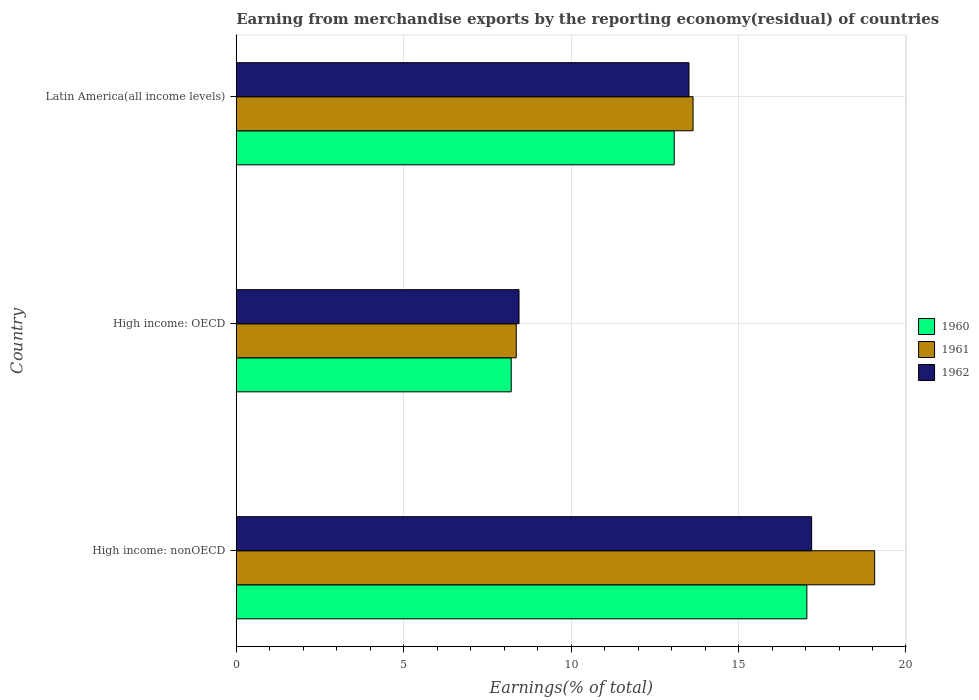How many different coloured bars are there?
Make the answer very short. 3. How many bars are there on the 2nd tick from the bottom?
Keep it short and to the point. 3. What is the label of the 1st group of bars from the top?
Give a very brief answer. Latin America(all income levels). What is the percentage of amount earned from merchandise exports in 1961 in Latin America(all income levels)?
Offer a very short reply. 13.64. Across all countries, what is the maximum percentage of amount earned from merchandise exports in 1960?
Give a very brief answer. 17.04. Across all countries, what is the minimum percentage of amount earned from merchandise exports in 1961?
Your answer should be very brief. 8.36. In which country was the percentage of amount earned from merchandise exports in 1961 maximum?
Offer a very short reply. High income: nonOECD. In which country was the percentage of amount earned from merchandise exports in 1960 minimum?
Make the answer very short. High income: OECD. What is the total percentage of amount earned from merchandise exports in 1961 in the graph?
Offer a terse response. 41.07. What is the difference between the percentage of amount earned from merchandise exports in 1960 in High income: OECD and that in High income: nonOECD?
Provide a succinct answer. -8.83. What is the difference between the percentage of amount earned from merchandise exports in 1961 in High income: OECD and the percentage of amount earned from merchandise exports in 1962 in High income: nonOECD?
Ensure brevity in your answer.  -8.82. What is the average percentage of amount earned from merchandise exports in 1962 per country?
Offer a terse response. 13.05. What is the difference between the percentage of amount earned from merchandise exports in 1960 and percentage of amount earned from merchandise exports in 1961 in High income: OECD?
Provide a short and direct response. -0.15. In how many countries, is the percentage of amount earned from merchandise exports in 1961 greater than 6 %?
Offer a very short reply. 3. What is the ratio of the percentage of amount earned from merchandise exports in 1960 in High income: OECD to that in Latin America(all income levels)?
Offer a terse response. 0.63. What is the difference between the highest and the second highest percentage of amount earned from merchandise exports in 1962?
Your answer should be compact. 3.66. What is the difference between the highest and the lowest percentage of amount earned from merchandise exports in 1960?
Your response must be concise. 8.83. In how many countries, is the percentage of amount earned from merchandise exports in 1961 greater than the average percentage of amount earned from merchandise exports in 1961 taken over all countries?
Keep it short and to the point. 1. What does the 3rd bar from the top in Latin America(all income levels) represents?
Ensure brevity in your answer.  1960. Are all the bars in the graph horizontal?
Your response must be concise. Yes. How many countries are there in the graph?
Offer a very short reply. 3. Are the values on the major ticks of X-axis written in scientific E-notation?
Your response must be concise. No. How many legend labels are there?
Offer a terse response. 3. How are the legend labels stacked?
Offer a very short reply. Vertical. What is the title of the graph?
Offer a terse response. Earning from merchandise exports by the reporting economy(residual) of countries. What is the label or title of the X-axis?
Provide a short and direct response. Earnings(% of total). What is the Earnings(% of total) of 1960 in High income: nonOECD?
Offer a terse response. 17.04. What is the Earnings(% of total) of 1961 in High income: nonOECD?
Provide a succinct answer. 19.06. What is the Earnings(% of total) of 1962 in High income: nonOECD?
Offer a terse response. 17.18. What is the Earnings(% of total) of 1960 in High income: OECD?
Offer a terse response. 8.21. What is the Earnings(% of total) of 1961 in High income: OECD?
Provide a succinct answer. 8.36. What is the Earnings(% of total) in 1962 in High income: OECD?
Ensure brevity in your answer.  8.44. What is the Earnings(% of total) in 1960 in Latin America(all income levels)?
Give a very brief answer. 13.08. What is the Earnings(% of total) of 1961 in Latin America(all income levels)?
Your answer should be very brief. 13.64. What is the Earnings(% of total) in 1962 in Latin America(all income levels)?
Provide a short and direct response. 13.52. Across all countries, what is the maximum Earnings(% of total) of 1960?
Offer a terse response. 17.04. Across all countries, what is the maximum Earnings(% of total) in 1961?
Your response must be concise. 19.06. Across all countries, what is the maximum Earnings(% of total) of 1962?
Your answer should be compact. 17.18. Across all countries, what is the minimum Earnings(% of total) of 1960?
Your response must be concise. 8.21. Across all countries, what is the minimum Earnings(% of total) of 1961?
Make the answer very short. 8.36. Across all countries, what is the minimum Earnings(% of total) of 1962?
Provide a short and direct response. 8.44. What is the total Earnings(% of total) in 1960 in the graph?
Ensure brevity in your answer.  38.33. What is the total Earnings(% of total) in 1961 in the graph?
Your answer should be very brief. 41.07. What is the total Earnings(% of total) in 1962 in the graph?
Offer a terse response. 39.15. What is the difference between the Earnings(% of total) in 1960 in High income: nonOECD and that in High income: OECD?
Provide a succinct answer. 8.83. What is the difference between the Earnings(% of total) of 1961 in High income: nonOECD and that in High income: OECD?
Offer a very short reply. 10.7. What is the difference between the Earnings(% of total) in 1962 in High income: nonOECD and that in High income: OECD?
Offer a very short reply. 8.74. What is the difference between the Earnings(% of total) in 1960 in High income: nonOECD and that in Latin America(all income levels)?
Your answer should be very brief. 3.96. What is the difference between the Earnings(% of total) in 1961 in High income: nonOECD and that in Latin America(all income levels)?
Keep it short and to the point. 5.42. What is the difference between the Earnings(% of total) of 1962 in High income: nonOECD and that in Latin America(all income levels)?
Your answer should be compact. 3.66. What is the difference between the Earnings(% of total) in 1960 in High income: OECD and that in Latin America(all income levels)?
Offer a terse response. -4.87. What is the difference between the Earnings(% of total) in 1961 in High income: OECD and that in Latin America(all income levels)?
Make the answer very short. -5.28. What is the difference between the Earnings(% of total) in 1962 in High income: OECD and that in Latin America(all income levels)?
Keep it short and to the point. -5.08. What is the difference between the Earnings(% of total) in 1960 in High income: nonOECD and the Earnings(% of total) in 1961 in High income: OECD?
Keep it short and to the point. 8.68. What is the difference between the Earnings(% of total) in 1960 in High income: nonOECD and the Earnings(% of total) in 1962 in High income: OECD?
Your response must be concise. 8.6. What is the difference between the Earnings(% of total) in 1961 in High income: nonOECD and the Earnings(% of total) in 1962 in High income: OECD?
Keep it short and to the point. 10.62. What is the difference between the Earnings(% of total) of 1960 in High income: nonOECD and the Earnings(% of total) of 1961 in Latin America(all income levels)?
Offer a terse response. 3.4. What is the difference between the Earnings(% of total) in 1960 in High income: nonOECD and the Earnings(% of total) in 1962 in Latin America(all income levels)?
Provide a short and direct response. 3.52. What is the difference between the Earnings(% of total) of 1961 in High income: nonOECD and the Earnings(% of total) of 1962 in Latin America(all income levels)?
Ensure brevity in your answer.  5.54. What is the difference between the Earnings(% of total) of 1960 in High income: OECD and the Earnings(% of total) of 1961 in Latin America(all income levels)?
Provide a short and direct response. -5.43. What is the difference between the Earnings(% of total) of 1960 in High income: OECD and the Earnings(% of total) of 1962 in Latin America(all income levels)?
Give a very brief answer. -5.31. What is the difference between the Earnings(% of total) of 1961 in High income: OECD and the Earnings(% of total) of 1962 in Latin America(all income levels)?
Give a very brief answer. -5.16. What is the average Earnings(% of total) in 1960 per country?
Offer a very short reply. 12.78. What is the average Earnings(% of total) in 1961 per country?
Give a very brief answer. 13.69. What is the average Earnings(% of total) of 1962 per country?
Make the answer very short. 13.05. What is the difference between the Earnings(% of total) of 1960 and Earnings(% of total) of 1961 in High income: nonOECD?
Your answer should be compact. -2.02. What is the difference between the Earnings(% of total) of 1960 and Earnings(% of total) of 1962 in High income: nonOECD?
Provide a succinct answer. -0.14. What is the difference between the Earnings(% of total) of 1961 and Earnings(% of total) of 1962 in High income: nonOECD?
Give a very brief answer. 1.88. What is the difference between the Earnings(% of total) of 1960 and Earnings(% of total) of 1961 in High income: OECD?
Provide a short and direct response. -0.15. What is the difference between the Earnings(% of total) in 1960 and Earnings(% of total) in 1962 in High income: OECD?
Your answer should be very brief. -0.23. What is the difference between the Earnings(% of total) in 1961 and Earnings(% of total) in 1962 in High income: OECD?
Ensure brevity in your answer.  -0.08. What is the difference between the Earnings(% of total) of 1960 and Earnings(% of total) of 1961 in Latin America(all income levels)?
Offer a very short reply. -0.56. What is the difference between the Earnings(% of total) in 1960 and Earnings(% of total) in 1962 in Latin America(all income levels)?
Keep it short and to the point. -0.44. What is the difference between the Earnings(% of total) of 1961 and Earnings(% of total) of 1962 in Latin America(all income levels)?
Offer a terse response. 0.12. What is the ratio of the Earnings(% of total) of 1960 in High income: nonOECD to that in High income: OECD?
Give a very brief answer. 2.08. What is the ratio of the Earnings(% of total) of 1961 in High income: nonOECD to that in High income: OECD?
Make the answer very short. 2.28. What is the ratio of the Earnings(% of total) in 1962 in High income: nonOECD to that in High income: OECD?
Provide a succinct answer. 2.03. What is the ratio of the Earnings(% of total) in 1960 in High income: nonOECD to that in Latin America(all income levels)?
Provide a succinct answer. 1.3. What is the ratio of the Earnings(% of total) of 1961 in High income: nonOECD to that in Latin America(all income levels)?
Give a very brief answer. 1.4. What is the ratio of the Earnings(% of total) in 1962 in High income: nonOECD to that in Latin America(all income levels)?
Keep it short and to the point. 1.27. What is the ratio of the Earnings(% of total) in 1960 in High income: OECD to that in Latin America(all income levels)?
Offer a very short reply. 0.63. What is the ratio of the Earnings(% of total) of 1961 in High income: OECD to that in Latin America(all income levels)?
Keep it short and to the point. 0.61. What is the ratio of the Earnings(% of total) in 1962 in High income: OECD to that in Latin America(all income levels)?
Provide a short and direct response. 0.62. What is the difference between the highest and the second highest Earnings(% of total) of 1960?
Ensure brevity in your answer.  3.96. What is the difference between the highest and the second highest Earnings(% of total) in 1961?
Ensure brevity in your answer.  5.42. What is the difference between the highest and the second highest Earnings(% of total) in 1962?
Your answer should be compact. 3.66. What is the difference between the highest and the lowest Earnings(% of total) in 1960?
Your answer should be compact. 8.83. What is the difference between the highest and the lowest Earnings(% of total) of 1961?
Provide a succinct answer. 10.7. What is the difference between the highest and the lowest Earnings(% of total) in 1962?
Your answer should be very brief. 8.74. 